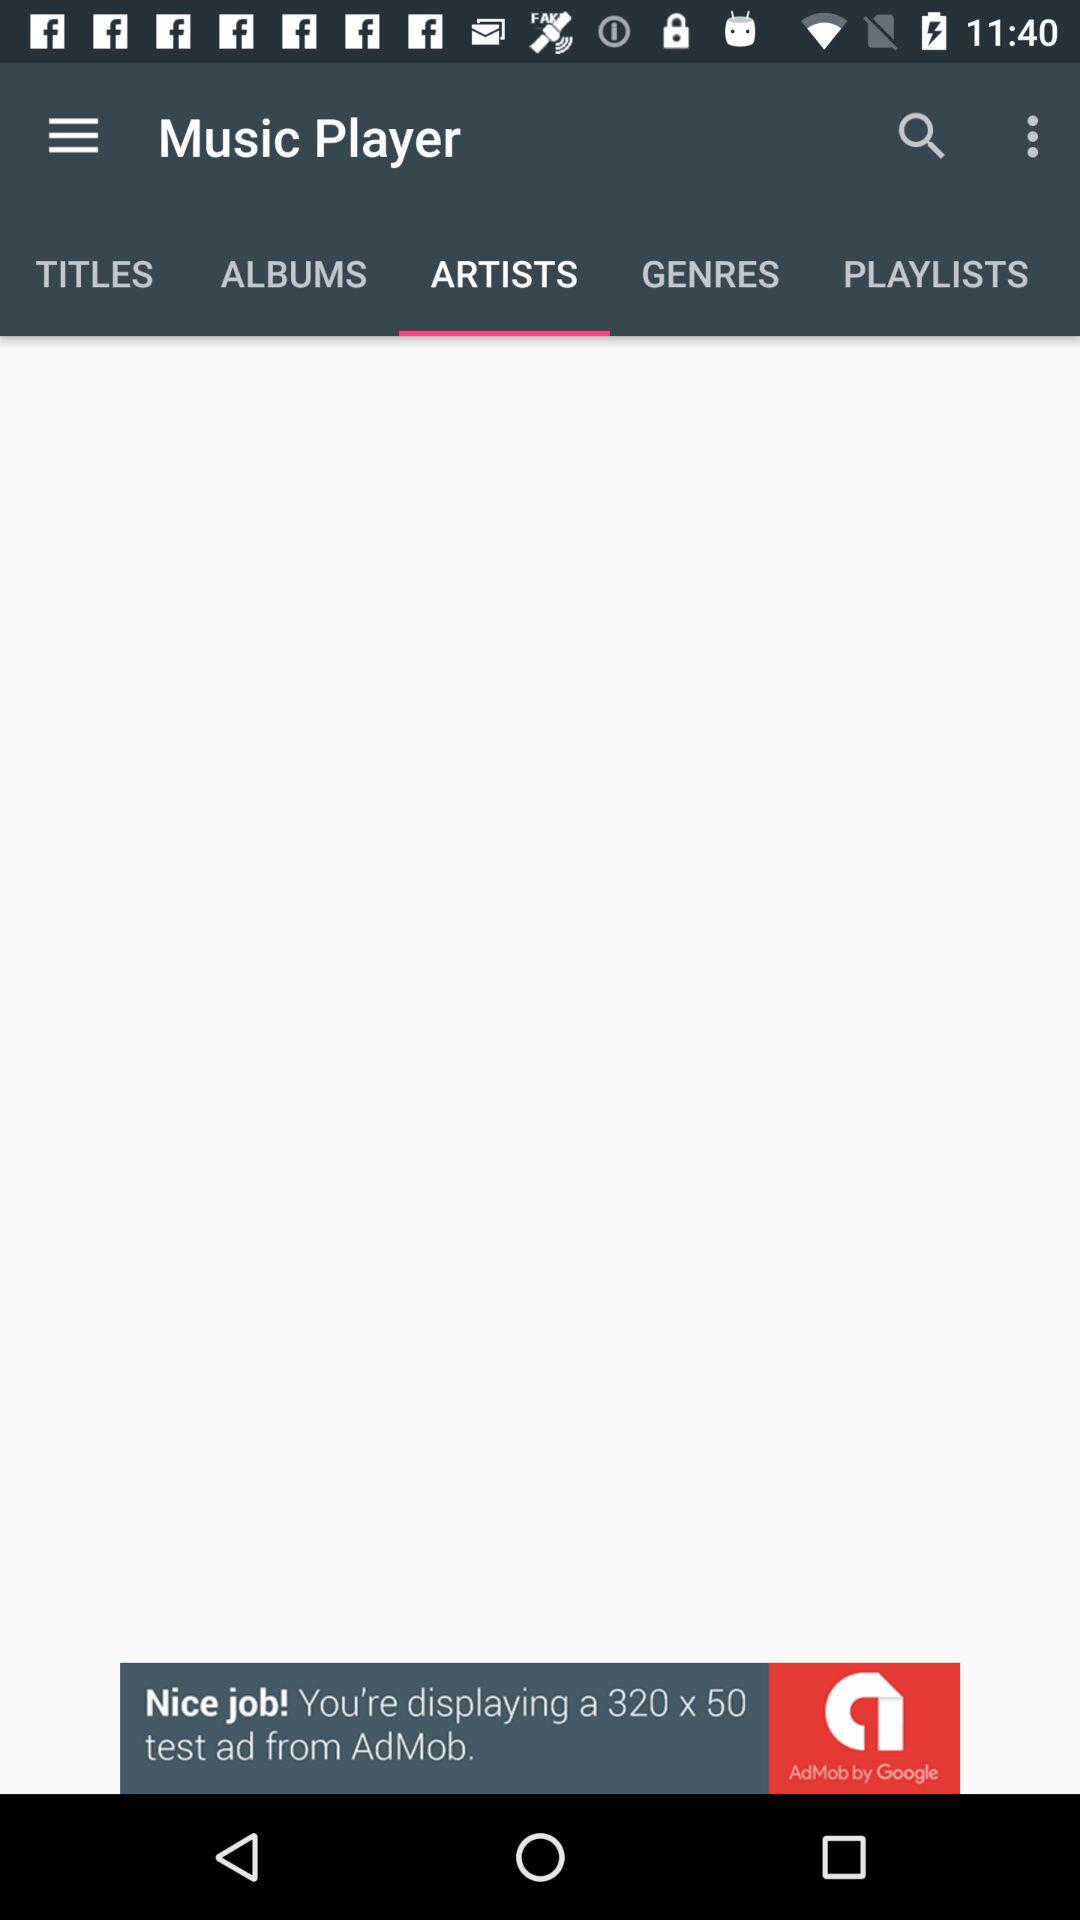In which category of "Music Player" am I? You are in the "ARTISTS" category of "Music Player". 